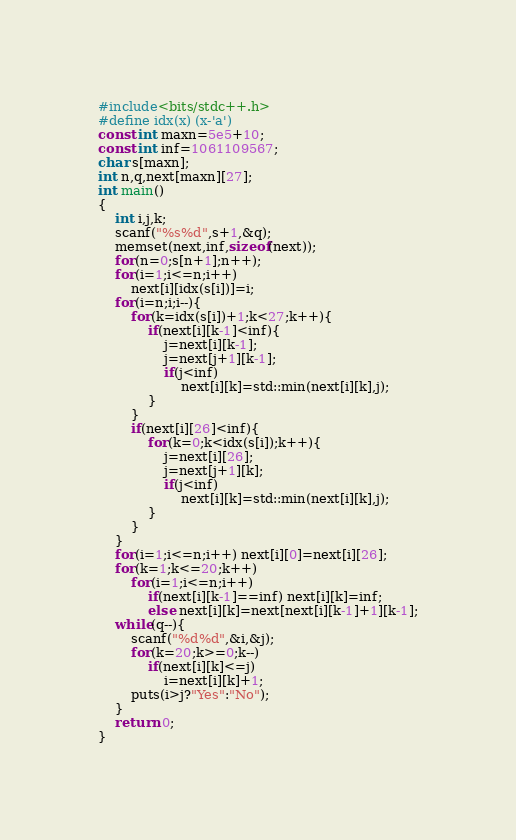Convert code to text. <code><loc_0><loc_0><loc_500><loc_500><_C++_>#include<bits/stdc++.h>
#define idx(x) (x-'a')
const int maxn=5e5+10;
const int inf=1061109567;
char s[maxn];
int n,q,next[maxn][27];
int main()
{
    int i,j,k;
    scanf("%s%d",s+1,&q);
    memset(next,inf,sizeof(next));
    for(n=0;s[n+1];n++); 
    for(i=1;i<=n;i++)
        next[i][idx(s[i])]=i;
    for(i=n;i;i--){
        for(k=idx(s[i])+1;k<27;k++){
            if(next[i][k-1]<inf){
                j=next[i][k-1];
                j=next[j+1][k-1];
                if(j<inf)
                    next[i][k]=std::min(next[i][k],j);
            }
        }
        if(next[i][26]<inf){
            for(k=0;k<idx(s[i]);k++){
                j=next[i][26];
                j=next[j+1][k];
                if(j<inf)
                    next[i][k]=std::min(next[i][k],j);
            }
        }
    }
    for(i=1;i<=n;i++) next[i][0]=next[i][26];
    for(k=1;k<=20;k++)
        for(i=1;i<=n;i++)
            if(next[i][k-1]==inf) next[i][k]=inf;
            else next[i][k]=next[next[i][k-1]+1][k-1];
    while(q--){
        scanf("%d%d",&i,&j);
        for(k=20;k>=0;k--)
            if(next[i][k]<=j)
                i=next[i][k]+1;
        puts(i>j?"Yes":"No");
    }
    return 0;
}</code> 